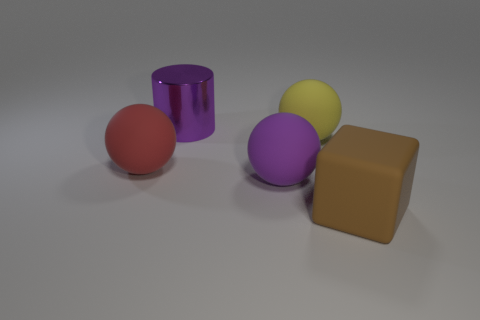What is the color of the matte ball to the left of the large metallic cylinder?
Your answer should be very brief. Red. Are there any other things that are the same color as the shiny cylinder?
Offer a very short reply. Yes. Is the size of the red matte ball the same as the rubber block?
Make the answer very short. Yes. There is a thing that is both behind the red ball and on the right side of the purple metallic cylinder; how big is it?
Offer a very short reply. Large. What number of red spheres have the same material as the yellow object?
Your answer should be compact. 1. What shape is the other large thing that is the same color as the large metallic object?
Make the answer very short. Sphere. The metal object has what color?
Make the answer very short. Purple. Do the purple object in front of the large yellow matte sphere and the brown rubber object have the same shape?
Keep it short and to the point. No. How many objects are either big balls on the right side of the big purple metal cylinder or small cyan things?
Provide a succinct answer. 2. Are there any large blue objects of the same shape as the big yellow thing?
Offer a terse response. No. 